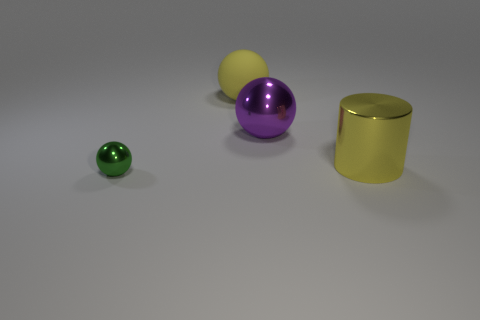Are there any other things that are the same size as the green metal object?
Ensure brevity in your answer.  No. Is there any other thing that has the same material as the large yellow sphere?
Make the answer very short. No. The green sphere that is made of the same material as the big purple object is what size?
Offer a very short reply. Small. What size is the metallic object left of the large purple thing?
Your response must be concise. Small. There is a sphere that is the same color as the large cylinder; what size is it?
Your answer should be very brief. Large. Do the purple ball and the yellow sphere have the same material?
Your response must be concise. No. There is a metal cylinder; is its color the same as the big sphere left of the purple shiny object?
Your answer should be compact. Yes. How many spheres are green metallic objects or gray things?
Keep it short and to the point. 1. Are there any other things of the same color as the small metal object?
Ensure brevity in your answer.  No. There is a yellow thing left of the shiny thing to the right of the big purple object; what is it made of?
Your response must be concise. Rubber. 